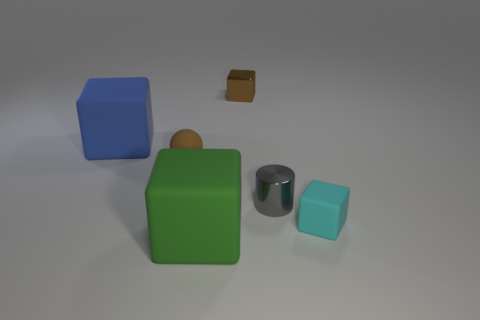Are there the same number of large green rubber things that are right of the shiny cylinder and balls?
Ensure brevity in your answer.  No. How many things are either big yellow rubber cylinders or big rubber blocks?
Your response must be concise. 2. The brown thing that is made of the same material as the blue block is what shape?
Keep it short and to the point. Sphere. There is a rubber object that is on the left side of the small brown sphere right of the big blue rubber object; how big is it?
Keep it short and to the point. Large. What number of small things are either gray metal things or cyan metal spheres?
Offer a terse response. 1. How many other things are the same color as the small rubber ball?
Keep it short and to the point. 1. Do the metal thing that is in front of the blue object and the object on the left side of the brown matte ball have the same size?
Offer a terse response. No. Does the gray thing have the same material as the large cube behind the green matte thing?
Provide a succinct answer. No. Is the number of rubber blocks that are on the left side of the large green object greater than the number of matte things behind the cyan block?
Keep it short and to the point. No. There is a cube that is in front of the rubber thing that is to the right of the brown cube; what is its color?
Offer a terse response. Green. 